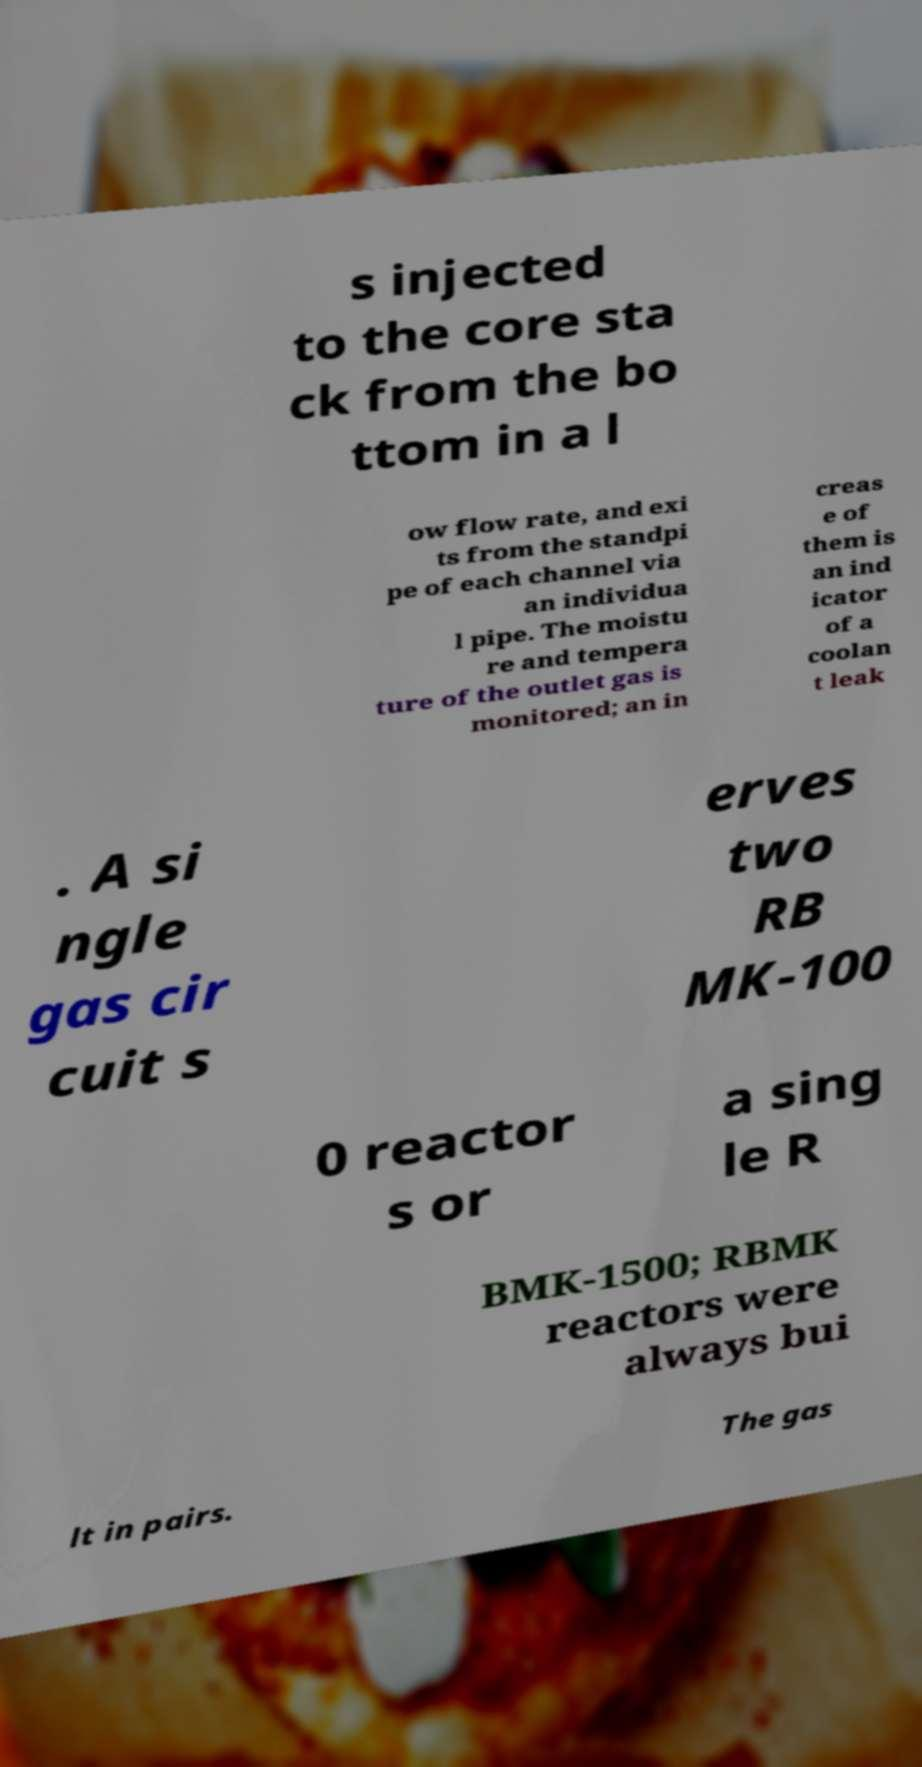Can you accurately transcribe the text from the provided image for me? s injected to the core sta ck from the bo ttom in a l ow flow rate, and exi ts from the standpi pe of each channel via an individua l pipe. The moistu re and tempera ture of the outlet gas is monitored; an in creas e of them is an ind icator of a coolan t leak . A si ngle gas cir cuit s erves two RB MK-100 0 reactor s or a sing le R BMK-1500; RBMK reactors were always bui lt in pairs. The gas 